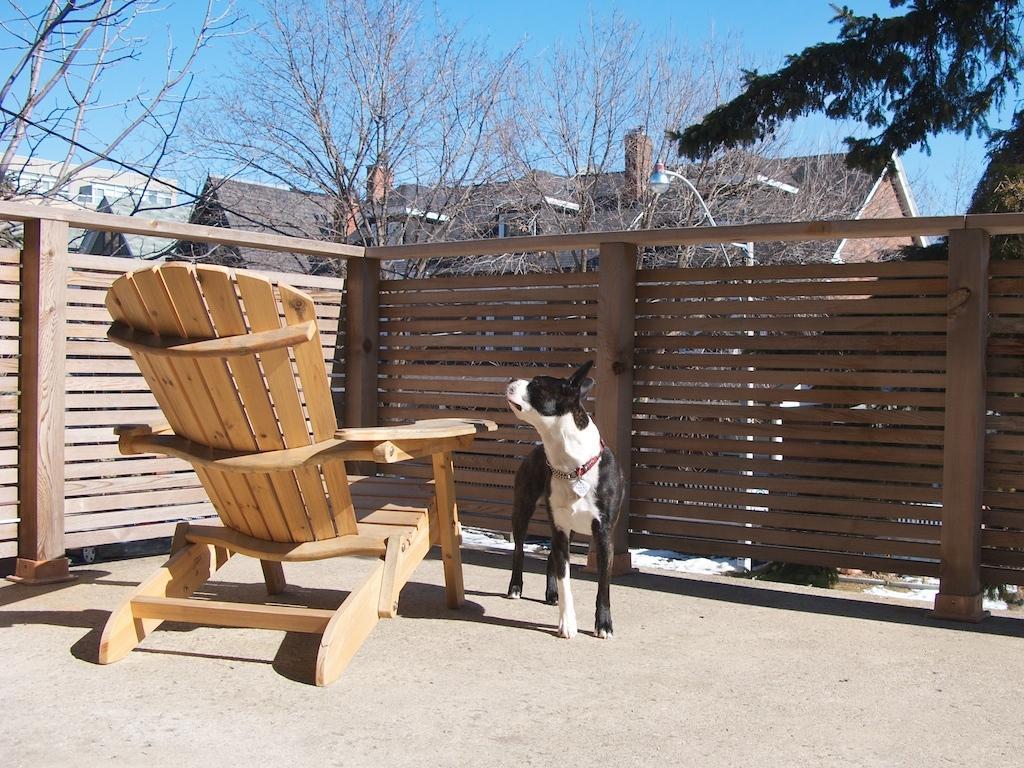Describe this image in one or two sentences. In this image I can see a wooden fence and wooden chair. Beside this chair there is a dog in black and white color. On the top of the image I can see the sky in blue color. On the top right corner of the image there is a tree. In the background I can see few buildings. 